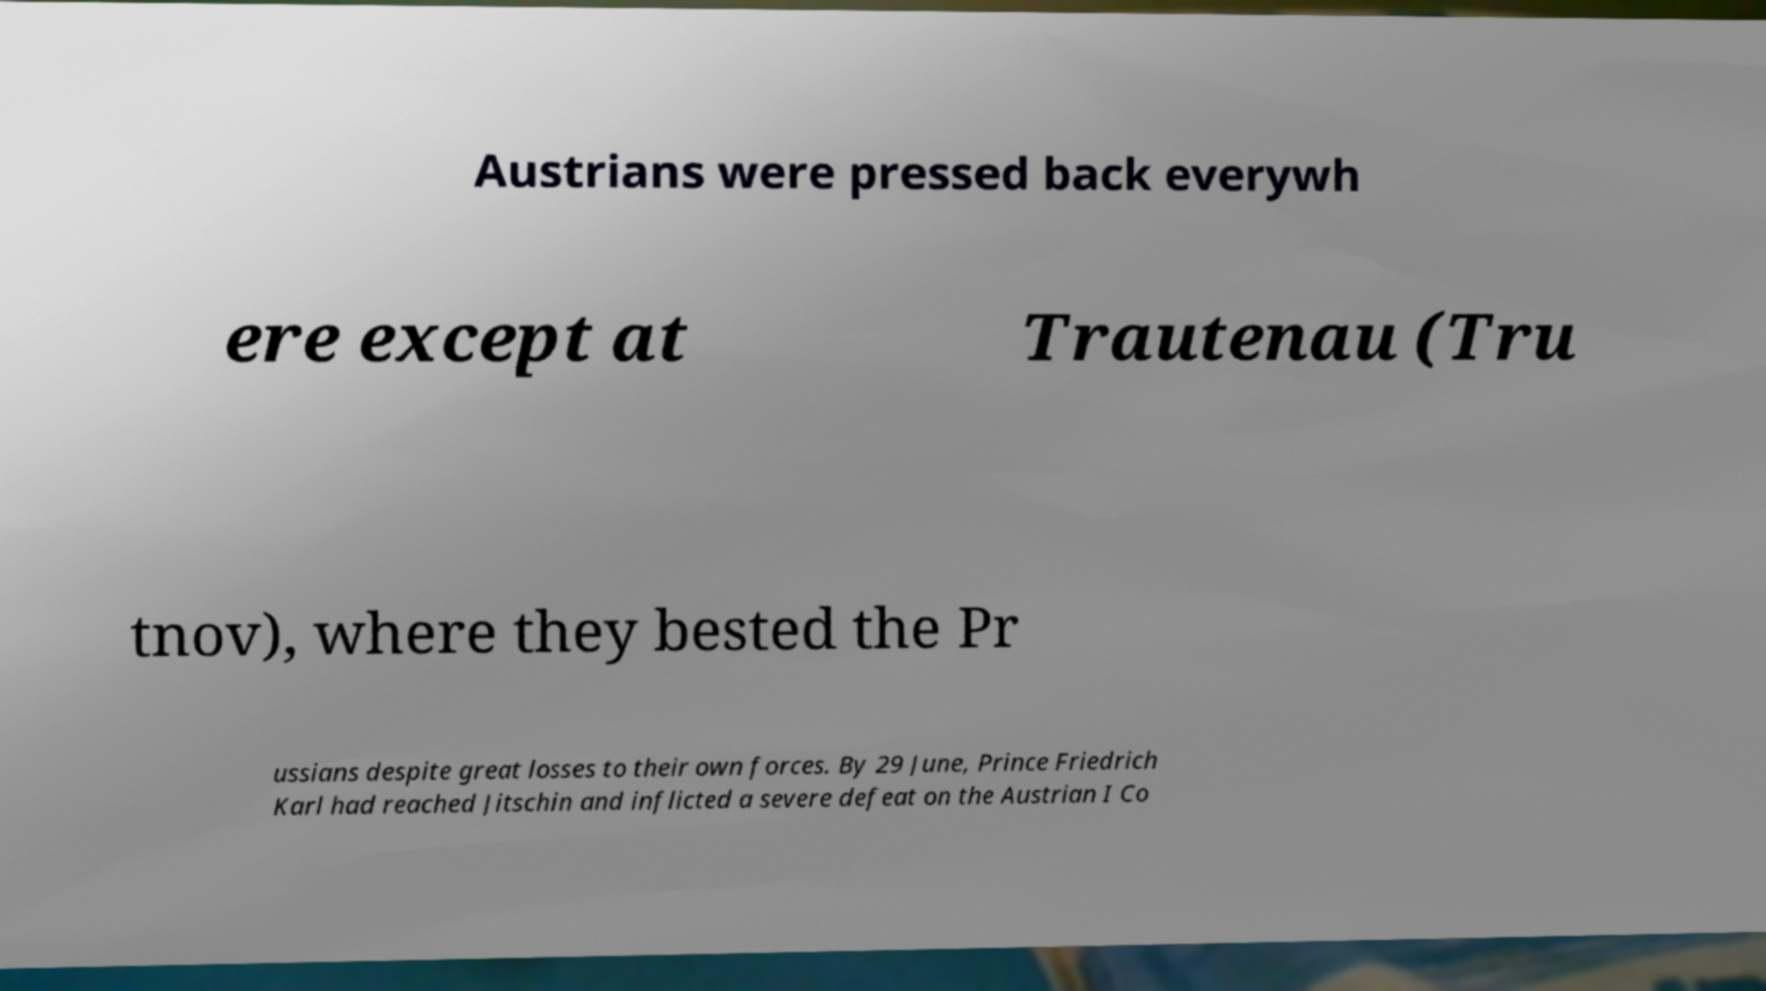Please identify and transcribe the text found in this image. Austrians were pressed back everywh ere except at Trautenau (Tru tnov), where they bested the Pr ussians despite great losses to their own forces. By 29 June, Prince Friedrich Karl had reached Jitschin and inflicted a severe defeat on the Austrian I Co 